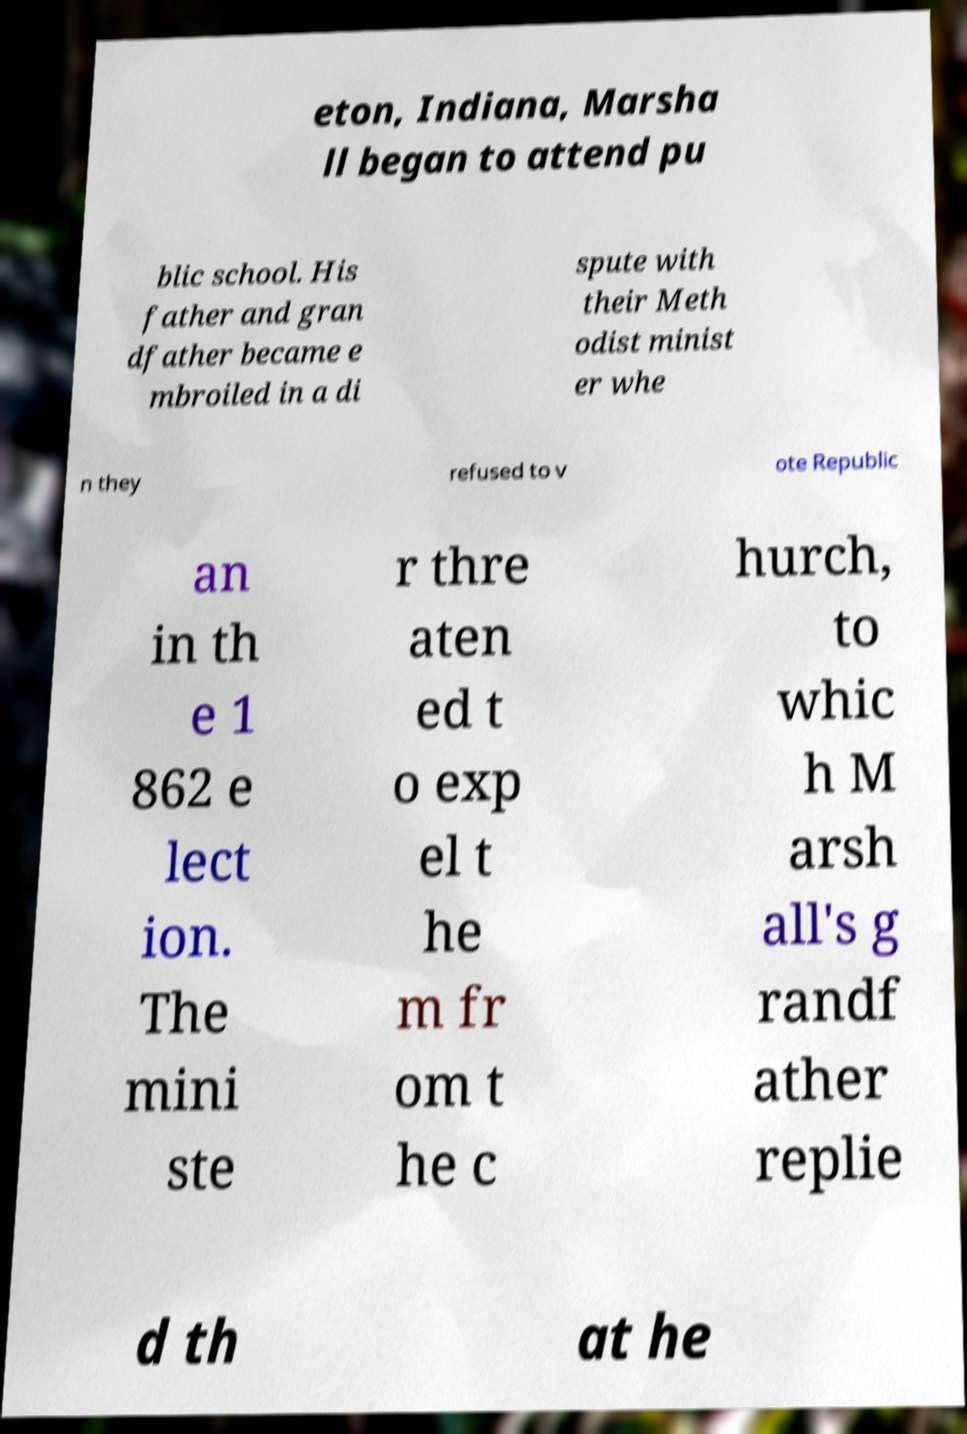Could you extract and type out the text from this image? eton, Indiana, Marsha ll began to attend pu blic school. His father and gran dfather became e mbroiled in a di spute with their Meth odist minist er whe n they refused to v ote Republic an in th e 1 862 e lect ion. The mini ste r thre aten ed t o exp el t he m fr om t he c hurch, to whic h M arsh all's g randf ather replie d th at he 